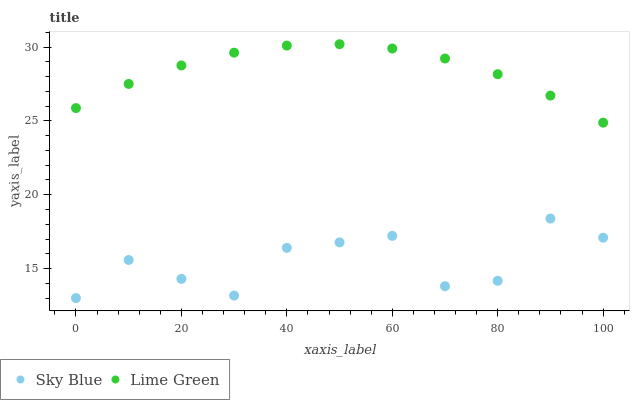Does Sky Blue have the minimum area under the curve?
Answer yes or no. Yes. Does Lime Green have the maximum area under the curve?
Answer yes or no. Yes. Does Lime Green have the minimum area under the curve?
Answer yes or no. No. Is Lime Green the smoothest?
Answer yes or no. Yes. Is Sky Blue the roughest?
Answer yes or no. Yes. Is Lime Green the roughest?
Answer yes or no. No. Does Sky Blue have the lowest value?
Answer yes or no. Yes. Does Lime Green have the lowest value?
Answer yes or no. No. Does Lime Green have the highest value?
Answer yes or no. Yes. Is Sky Blue less than Lime Green?
Answer yes or no. Yes. Is Lime Green greater than Sky Blue?
Answer yes or no. Yes. Does Sky Blue intersect Lime Green?
Answer yes or no. No. 